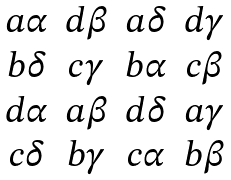<formula> <loc_0><loc_0><loc_500><loc_500>\begin{matrix} a \alpha & d \beta & a \delta & d \gamma \\ b \delta & c \gamma & b \alpha & c \beta \\ d \alpha & a \beta & d \delta & a \gamma \\ c \delta & b \gamma & c \alpha & b \beta \end{matrix}</formula> 